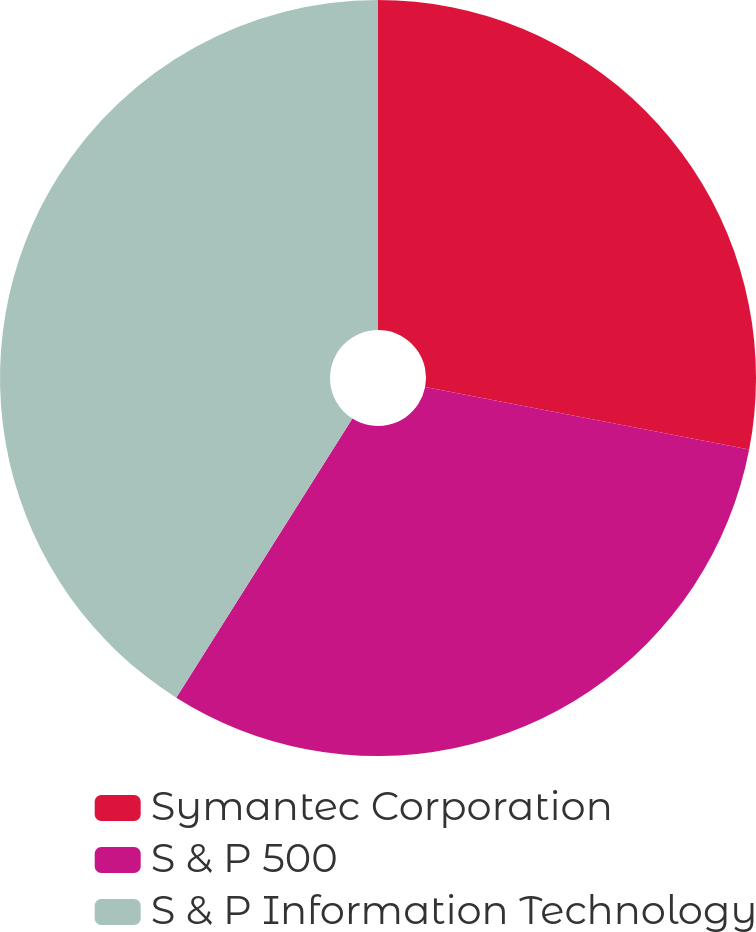Convert chart. <chart><loc_0><loc_0><loc_500><loc_500><pie_chart><fcel>Symantec Corporation<fcel>S & P 500<fcel>S & P Information Technology<nl><fcel>28.03%<fcel>30.93%<fcel>41.04%<nl></chart> 